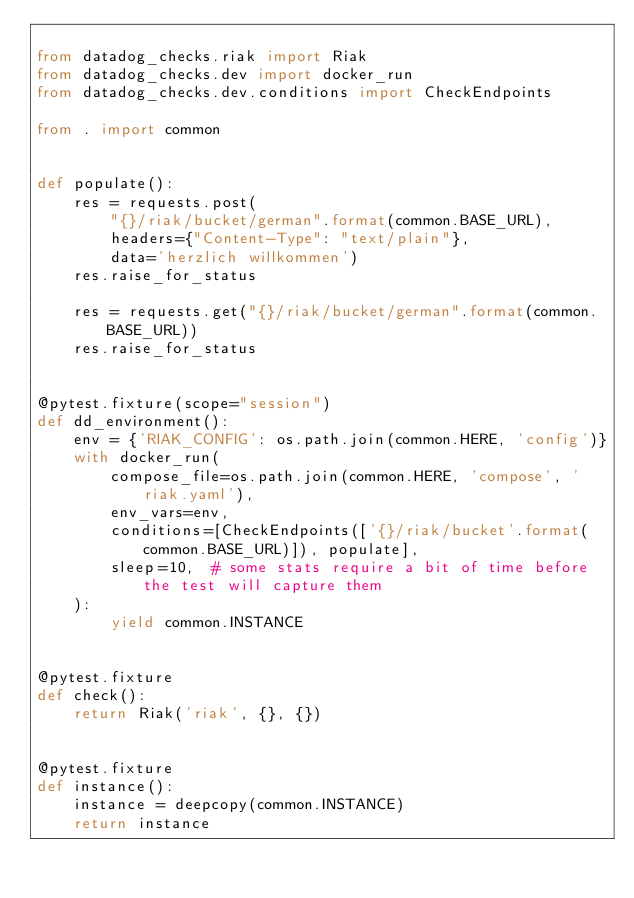Convert code to text. <code><loc_0><loc_0><loc_500><loc_500><_Python_>
from datadog_checks.riak import Riak
from datadog_checks.dev import docker_run
from datadog_checks.dev.conditions import CheckEndpoints

from . import common


def populate():
    res = requests.post(
        "{}/riak/bucket/german".format(common.BASE_URL),
        headers={"Content-Type": "text/plain"},
        data='herzlich willkommen')
    res.raise_for_status

    res = requests.get("{}/riak/bucket/german".format(common.BASE_URL))
    res.raise_for_status


@pytest.fixture(scope="session")
def dd_environment():
    env = {'RIAK_CONFIG': os.path.join(common.HERE, 'config')}
    with docker_run(
        compose_file=os.path.join(common.HERE, 'compose', 'riak.yaml'),
        env_vars=env,
        conditions=[CheckEndpoints(['{}/riak/bucket'.format(common.BASE_URL)]), populate],
        sleep=10,  # some stats require a bit of time before the test will capture them
    ):
        yield common.INSTANCE


@pytest.fixture
def check():
    return Riak('riak', {}, {})


@pytest.fixture
def instance():
    instance = deepcopy(common.INSTANCE)
    return instance
</code> 